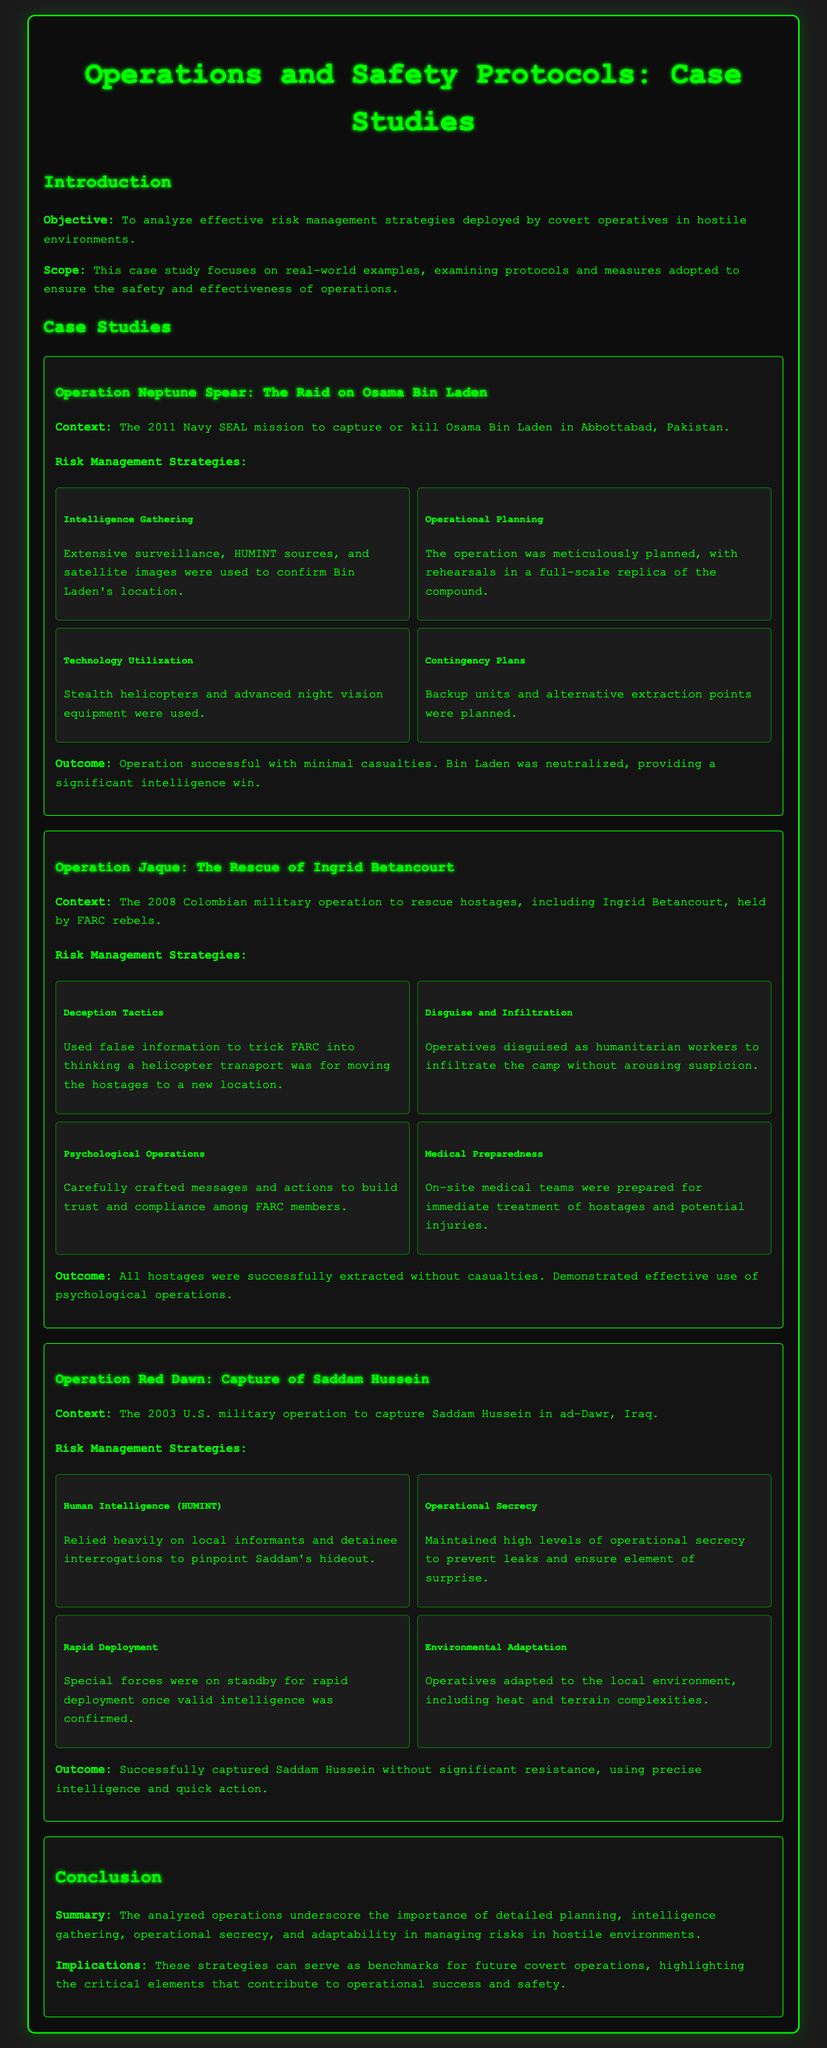What is the objective of the case study? The document states the objective is to analyze effective risk management strategies deployed by covert operatives in hostile environments.
Answer: To analyze effective risk management strategies What operation is associated with the rescue of Ingrid Betancourt? The case study specifically mentions the operation aimed at rescuing Ingrid Betancourt.
Answer: Operation Jaque How many risk management strategies are listed for Operation Neptune Spear? The document outlines four risk management strategies employed during Operation Neptune Spear.
Answer: Four What tactic was used in Operation Jaque to mislead FARC? The operation utilized false information to create a misleading scenario for FARC rebels.
Answer: Deception Tactics What was a critical element leading to the success of Operation Red Dawn? The case study emphasizes the reliance on local informants and detainee interrogations for locating Saddam Hussein.
Answer: Human Intelligence (HUMINT) What was the outcome of Operation Jaque? Operation Jaque had a successful outcome with all hostages extracted without casualties.
Answer: All hostages successfully extracted without casualties What technology was highlighted in Operation Neptune Spear? The case study mentions the use of advanced technology for stealth in the operation.
Answer: Stealth helicopters and advanced night vision equipment What year did Operation Red Dawn occur? The document specifies that Operation Red Dawn took place in the year 2003.
Answer: 2003 What was the main purpose of the medical teams in Operation Jaque? The case study indicates that medical teams were prepared for immediate treatment during the operation.
Answer: Immediate treatment of hostages and potential injuries 